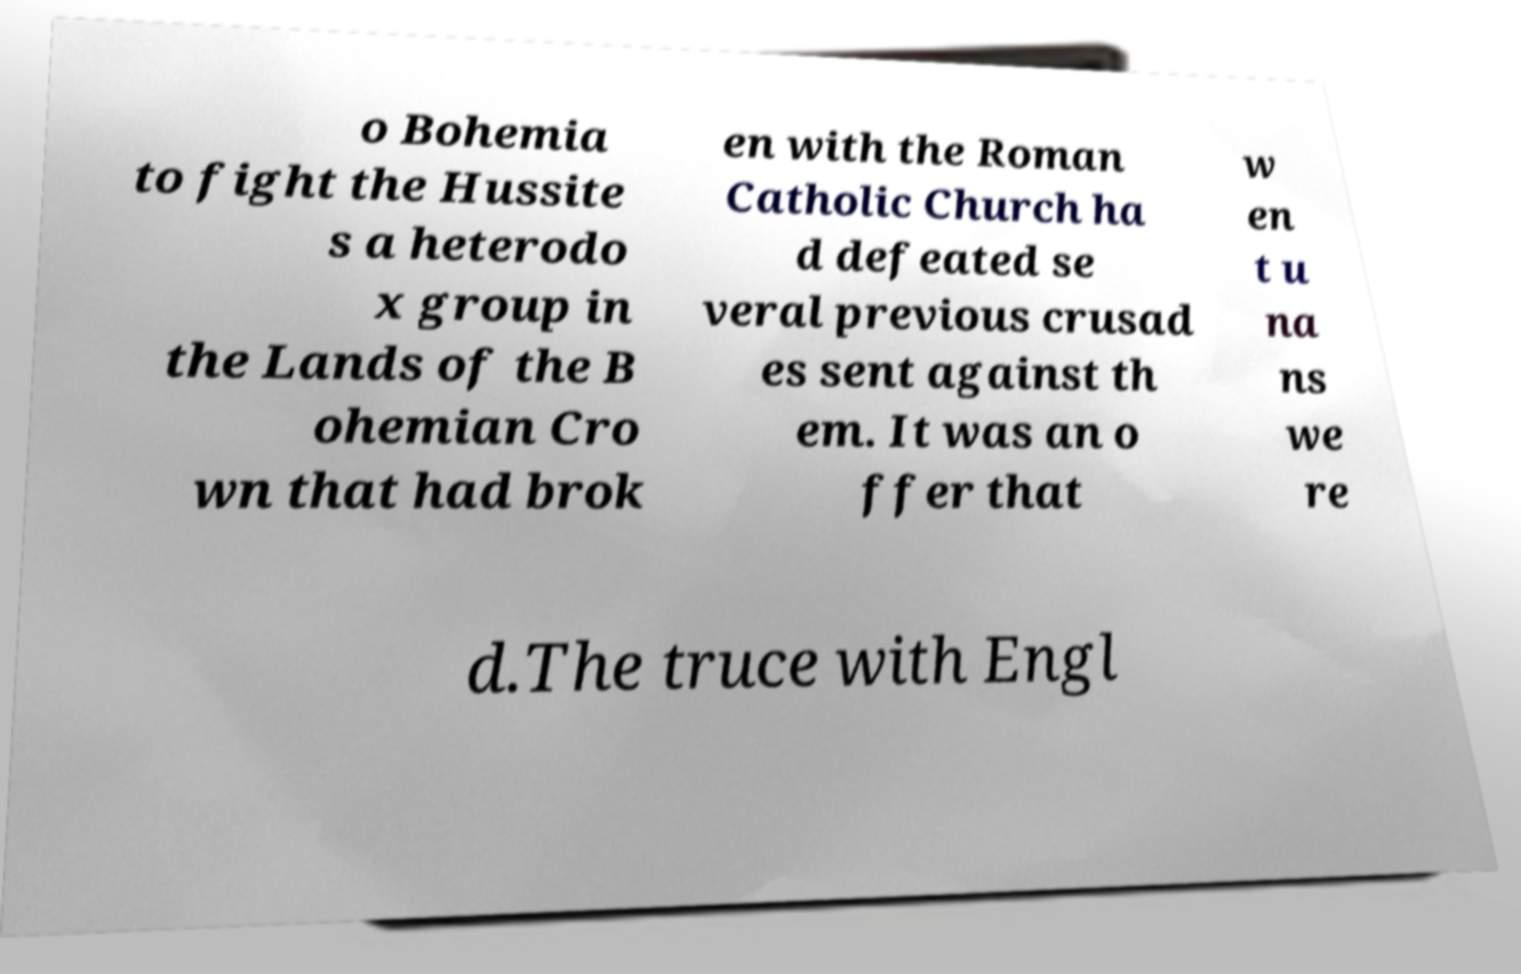Could you extract and type out the text from this image? o Bohemia to fight the Hussite s a heterodo x group in the Lands of the B ohemian Cro wn that had brok en with the Roman Catholic Church ha d defeated se veral previous crusad es sent against th em. It was an o ffer that w en t u na ns we re d.The truce with Engl 